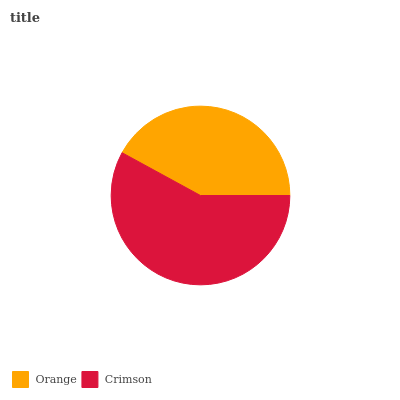Is Orange the minimum?
Answer yes or no. Yes. Is Crimson the maximum?
Answer yes or no. Yes. Is Crimson the minimum?
Answer yes or no. No. Is Crimson greater than Orange?
Answer yes or no. Yes. Is Orange less than Crimson?
Answer yes or no. Yes. Is Orange greater than Crimson?
Answer yes or no. No. Is Crimson less than Orange?
Answer yes or no. No. Is Crimson the high median?
Answer yes or no. Yes. Is Orange the low median?
Answer yes or no. Yes. Is Orange the high median?
Answer yes or no. No. Is Crimson the low median?
Answer yes or no. No. 